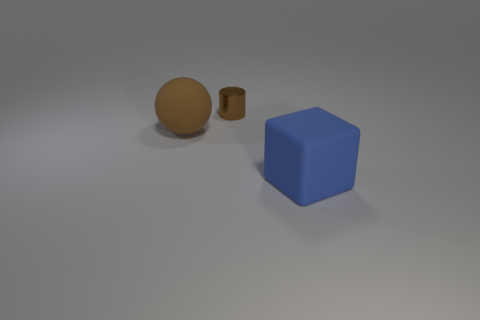Are the objects casting shadows and what does that tell us about the light source? Yes, each object is casting a soft shadow, which suggests there is a single light source above them creating a diffuse light. The shadows are subtle, indicating the light is not extremely close to the objects. 